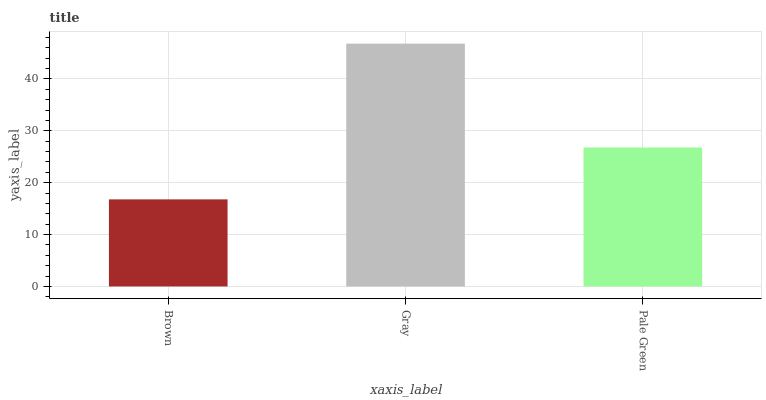Is Brown the minimum?
Answer yes or no. Yes. Is Gray the maximum?
Answer yes or no. Yes. Is Pale Green the minimum?
Answer yes or no. No. Is Pale Green the maximum?
Answer yes or no. No. Is Gray greater than Pale Green?
Answer yes or no. Yes. Is Pale Green less than Gray?
Answer yes or no. Yes. Is Pale Green greater than Gray?
Answer yes or no. No. Is Gray less than Pale Green?
Answer yes or no. No. Is Pale Green the high median?
Answer yes or no. Yes. Is Pale Green the low median?
Answer yes or no. Yes. Is Gray the high median?
Answer yes or no. No. Is Brown the low median?
Answer yes or no. No. 